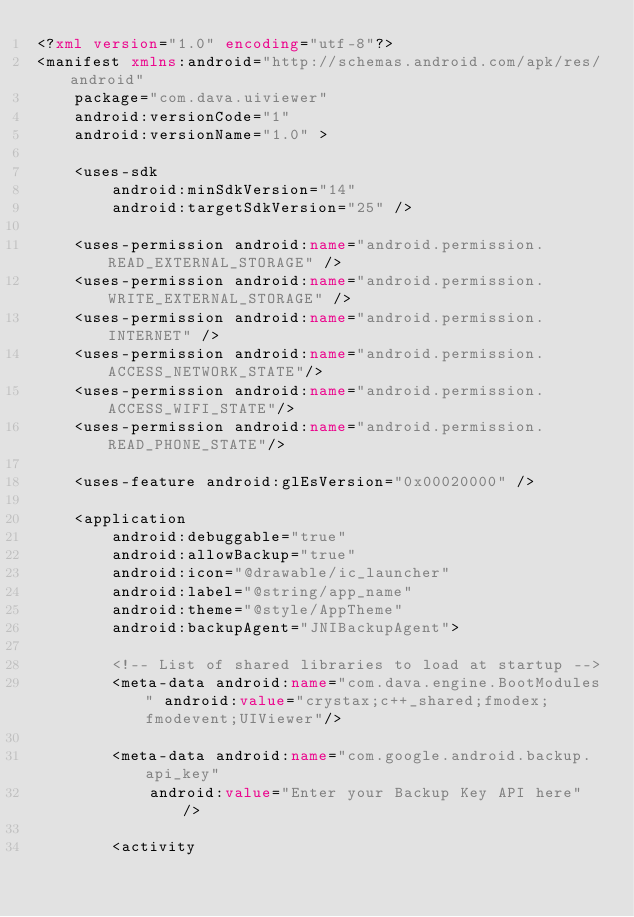Convert code to text. <code><loc_0><loc_0><loc_500><loc_500><_XML_><?xml version="1.0" encoding="utf-8"?>
<manifest xmlns:android="http://schemas.android.com/apk/res/android"
    package="com.dava.uiviewer"
    android:versionCode="1"
    android:versionName="1.0" >

    <uses-sdk
        android:minSdkVersion="14"
        android:targetSdkVersion="25" />

    <uses-permission android:name="android.permission.READ_EXTERNAL_STORAGE" />
    <uses-permission android:name="android.permission.WRITE_EXTERNAL_STORAGE" />
    <uses-permission android:name="android.permission.INTERNET" />
    <uses-permission android:name="android.permission.ACCESS_NETWORK_STATE"/>
    <uses-permission android:name="android.permission.ACCESS_WIFI_STATE"/>
    <uses-permission android:name="android.permission.READ_PHONE_STATE"/>

    <uses-feature android:glEsVersion="0x00020000" />

    <application
        android:debuggable="true"
        android:allowBackup="true"
        android:icon="@drawable/ic_launcher"
        android:label="@string/app_name"
        android:theme="@style/AppTheme"
        android:backupAgent="JNIBackupAgent">
        
        <!-- List of shared libraries to load at startup -->
        <meta-data android:name="com.dava.engine.BootModules" android:value="crystax;c++_shared;fmodex;fmodevent;UIViewer"/>
        
        <meta-data android:name="com.google.android.backup.api_key"
    		android:value="Enter your Backup Key API here" />

        <activity</code> 